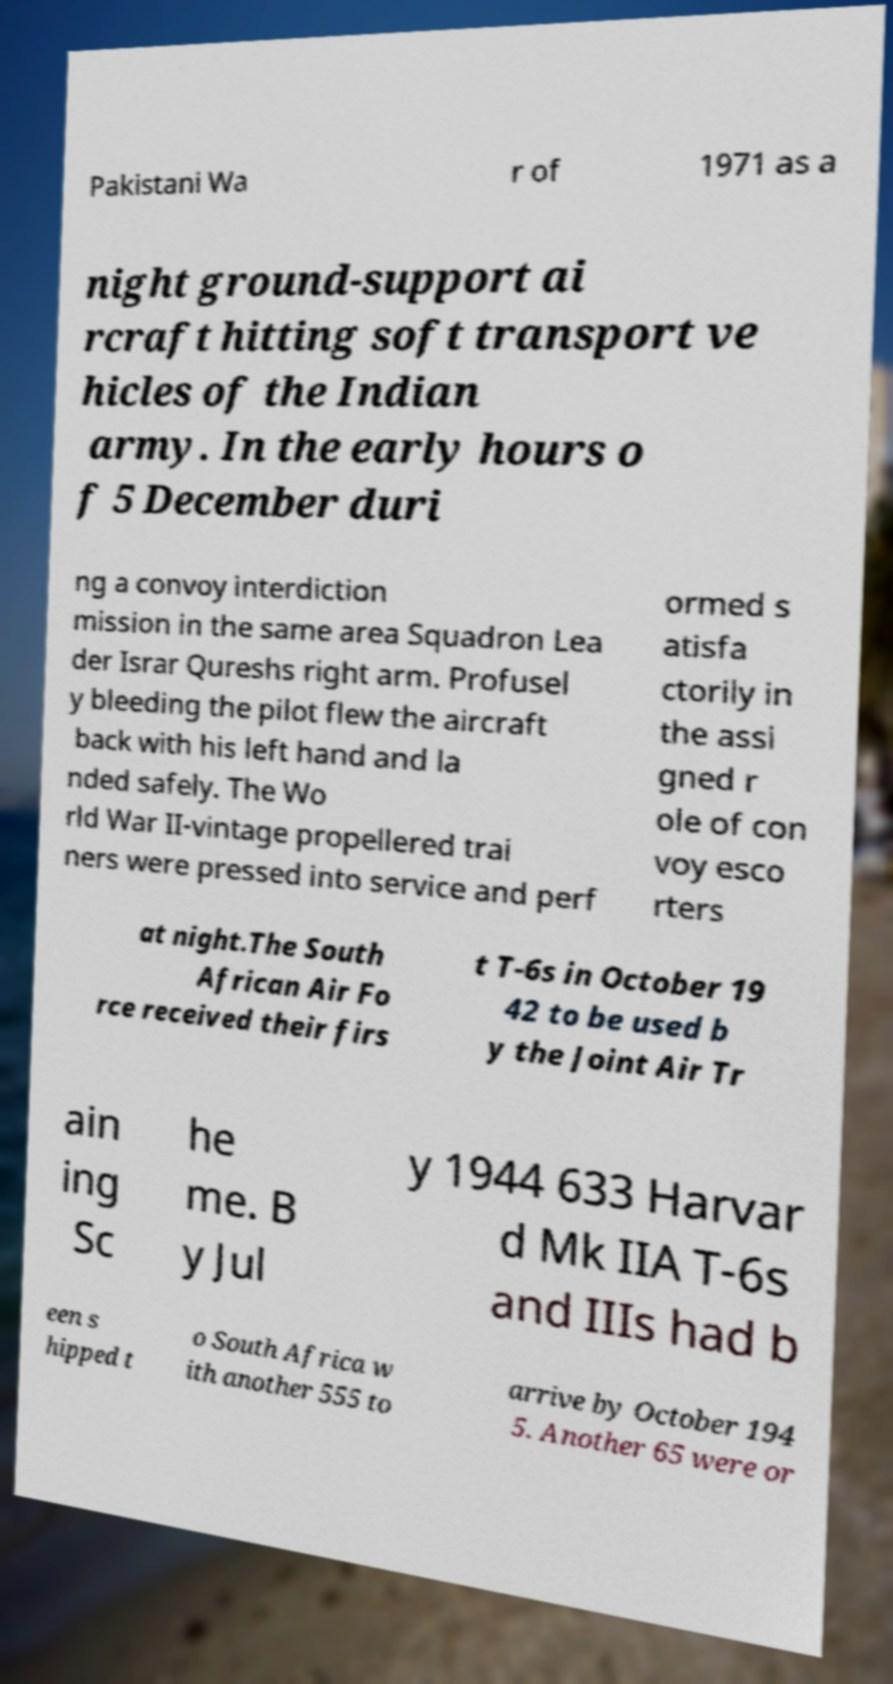Please identify and transcribe the text found in this image. Pakistani Wa r of 1971 as a night ground-support ai rcraft hitting soft transport ve hicles of the Indian army. In the early hours o f 5 December duri ng a convoy interdiction mission in the same area Squadron Lea der Israr Qureshs right arm. Profusel y bleeding the pilot flew the aircraft back with his left hand and la nded safely. The Wo rld War II-vintage propellered trai ners were pressed into service and perf ormed s atisfa ctorily in the assi gned r ole of con voy esco rters at night.The South African Air Fo rce received their firs t T-6s in October 19 42 to be used b y the Joint Air Tr ain ing Sc he me. B y Jul y 1944 633 Harvar d Mk IIA T-6s and IIIs had b een s hipped t o South Africa w ith another 555 to arrive by October 194 5. Another 65 were or 